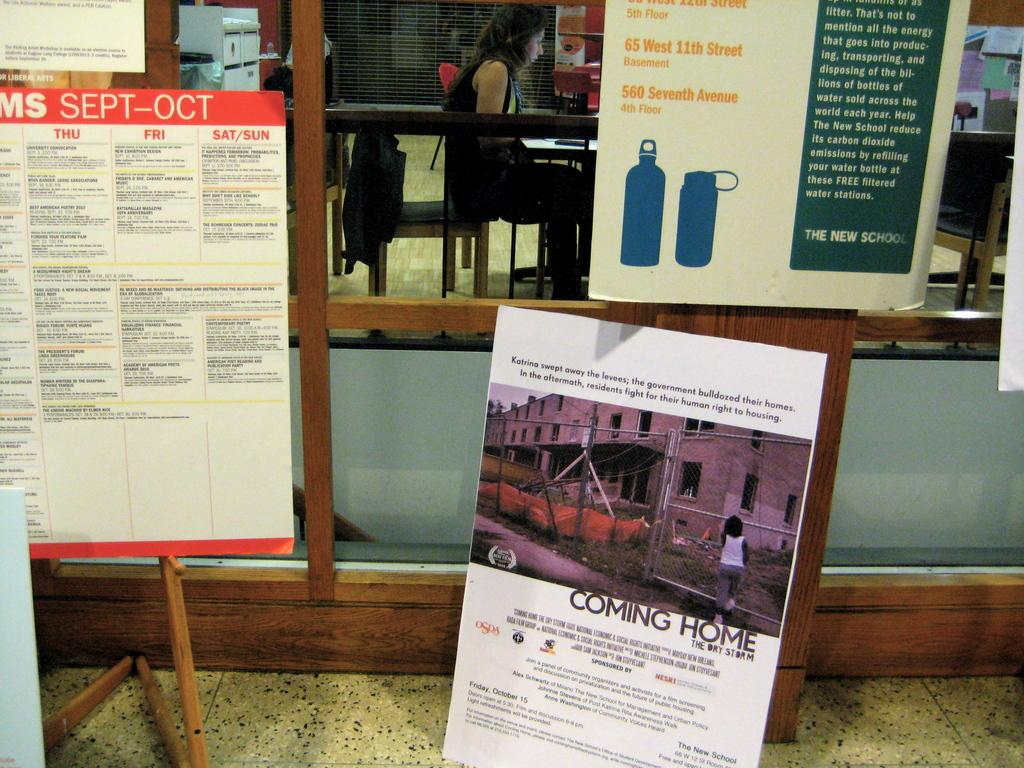<image>
Give a short and clear explanation of the subsequent image. Several posters, including one that says "Coming Home" on it, are on display. 